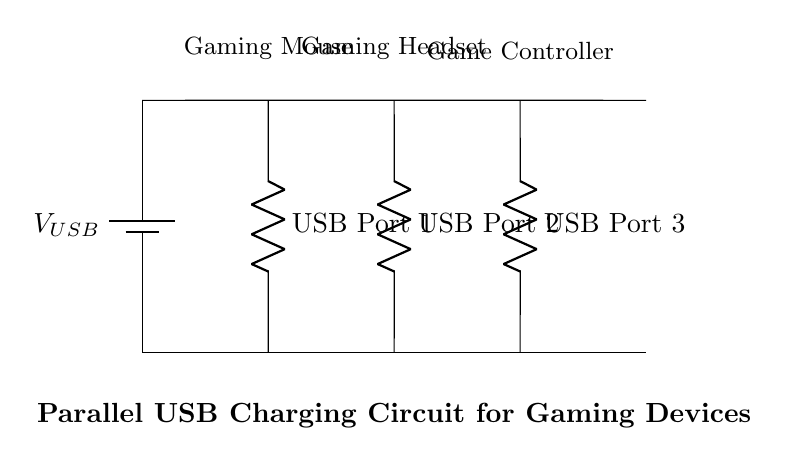What is the type of the circuit shown? The circuit is a parallel circuit since all USB ports are connected in parallel to the main power supply line. Each USB port has its own pathway for current to flow independently.
Answer: Parallel How many devices can be charged simultaneously? There are three USB ports in the circuit, which means three devices can be charged at the same time: a gaming mouse, a gaming headset, and a game controller.
Answer: Three What is the role of the battery in this circuit? The battery serves as the power supply for the USB ports, providing the necessary voltage for the devices to charge. It represents the power source of the computer.
Answer: Power supply If one USB port is in use, does it affect the other ports? No, since the ports are connected in parallel, using one port does not affect the others. Each port gets the same voltage directly from the power supply.
Answer: No What is the expected voltage at the USB ports? The expected voltage is indicated as V USB, which typically is 5 volts for USB power. Each port receives the same voltage as supplied by the battery.
Answer: Five volts What is the significance of using a parallel circuit for charging devices? A parallel circuit allows for multiple devices to draw current independently without reducing the voltage to each device, enhancing efficiency and charging speed.
Answer: Efficiency 